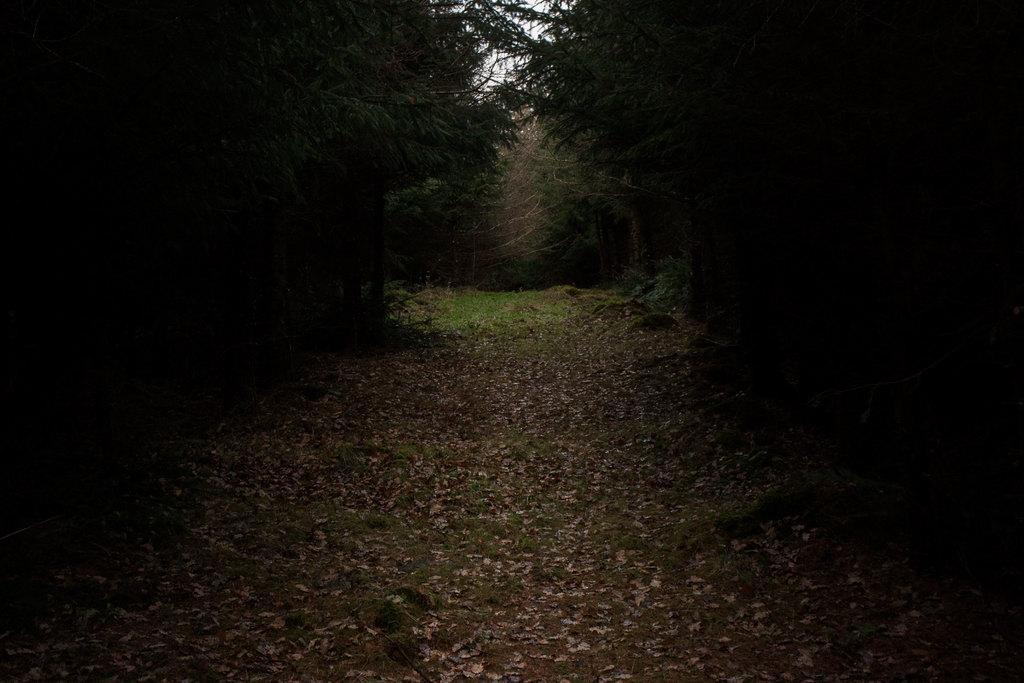Could you give a brief overview of what you see in this image? In this picture we can see dried leaves and grass on the ground and in the background we can see trees. 